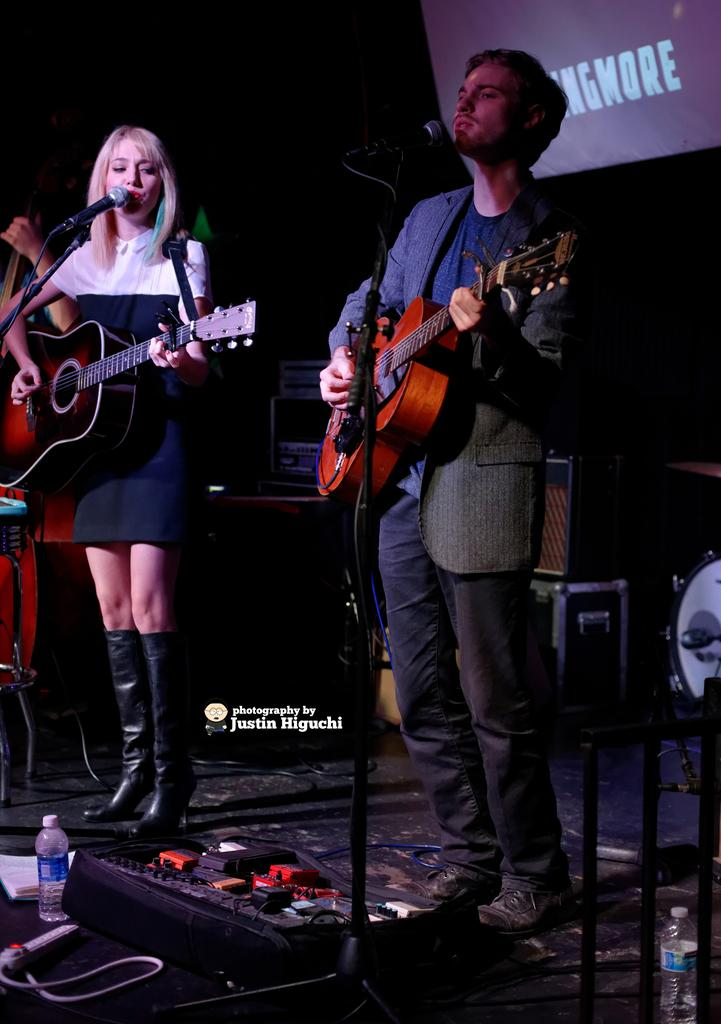How many people are in the image? There are two people in the image, a man and a woman. What are they doing in the image? They are playing guitars and singing on microphones. Where are they performing? They are standing on a stage. What other musical instruments can be seen on the stage? There are drums on the stage. What objects are present on the stage that are not musical instruments? There is a bottle and some books on the stage. What equipment is used to amplify their music? There are speakers on the stage. What type of stocking is the woman wearing in the image? There is no information about the woman's stockings in the image, so we cannot determine what type she is wearing. 